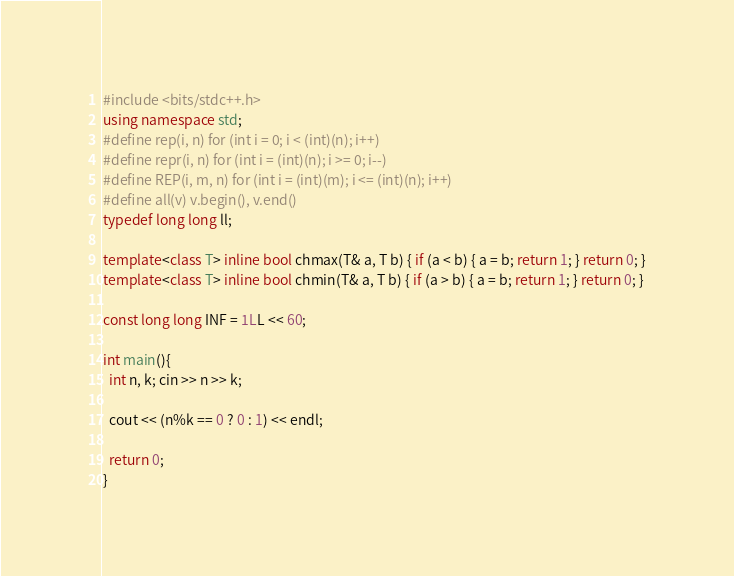<code> <loc_0><loc_0><loc_500><loc_500><_C++_>#include <bits/stdc++.h>
using namespace std;
#define rep(i, n) for (int i = 0; i < (int)(n); i++)
#define repr(i, n) for (int i = (int)(n); i >= 0; i--)
#define REP(i, m, n) for (int i = (int)(m); i <= (int)(n); i++)
#define all(v) v.begin(), v.end()
typedef long long ll;

template<class T> inline bool chmax(T& a, T b) { if (a < b) { a = b; return 1; } return 0; }
template<class T> inline bool chmin(T& a, T b) { if (a > b) { a = b; return 1; } return 0; }

const long long INF = 1LL << 60;

int main(){
  int n, k; cin >> n >> k;

  cout << (n%k == 0 ? 0 : 1) << endl;

  return 0;
}
</code> 